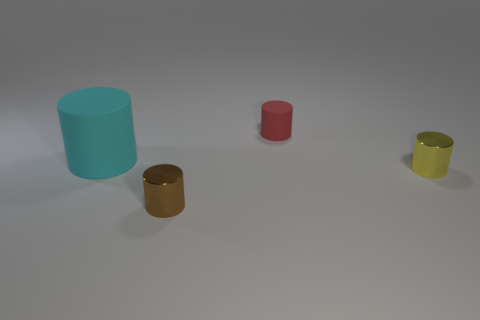How many brown metallic cylinders are the same size as the yellow metal thing?
Provide a short and direct response. 1. What number of small red matte cylinders are behind the small object that is behind the large cyan matte cylinder?
Keep it short and to the point. 0. What is the size of the cylinder that is both in front of the cyan rubber thing and left of the red rubber cylinder?
Provide a succinct answer. Small. Are there more brown objects than small red rubber cubes?
Your answer should be compact. Yes. Is the size of the object behind the cyan cylinder the same as the large cyan matte object?
Provide a short and direct response. No. Is the number of matte cylinders less than the number of red matte things?
Give a very brief answer. No. Are there any tiny yellow cylinders that have the same material as the small yellow object?
Give a very brief answer. No. Is the number of tiny red cylinders that are on the left side of the tiny brown thing less than the number of large rubber things?
Ensure brevity in your answer.  Yes. There is a small cylinder that is made of the same material as the big cyan cylinder; what is its color?
Ensure brevity in your answer.  Red. There is a cylinder to the right of the tiny red rubber cylinder; what is its size?
Keep it short and to the point. Small. 